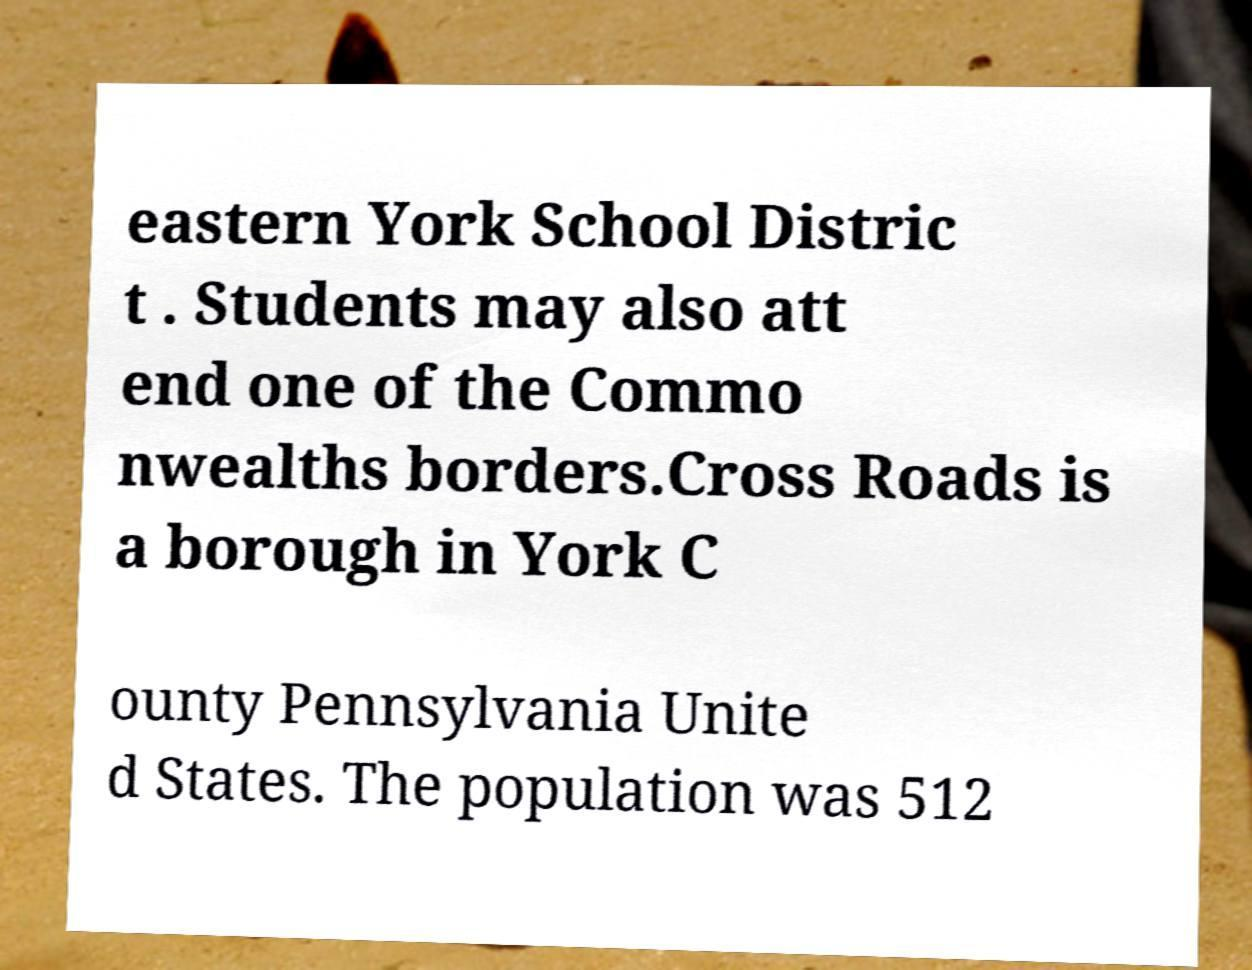I need the written content from this picture converted into text. Can you do that? eastern York School Distric t . Students may also att end one of the Commo nwealths borders.Cross Roads is a borough in York C ounty Pennsylvania Unite d States. The population was 512 